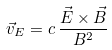<formula> <loc_0><loc_0><loc_500><loc_500>\vec { v } _ { E } = c \, \frac { { \vec { E } } \times { \vec { B } } } { B ^ { 2 } }</formula> 